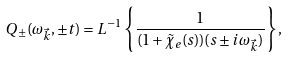Convert formula to latex. <formula><loc_0><loc_0><loc_500><loc_500>Q _ { \pm } ( \omega _ { \vec { k } } , \pm t ) = L ^ { - 1 } \left \{ \frac { 1 } { ( 1 + \tilde { \chi } _ { e } ( s ) ) ( s \pm i \omega _ { \vec { k } } ) } \right \} ,</formula> 